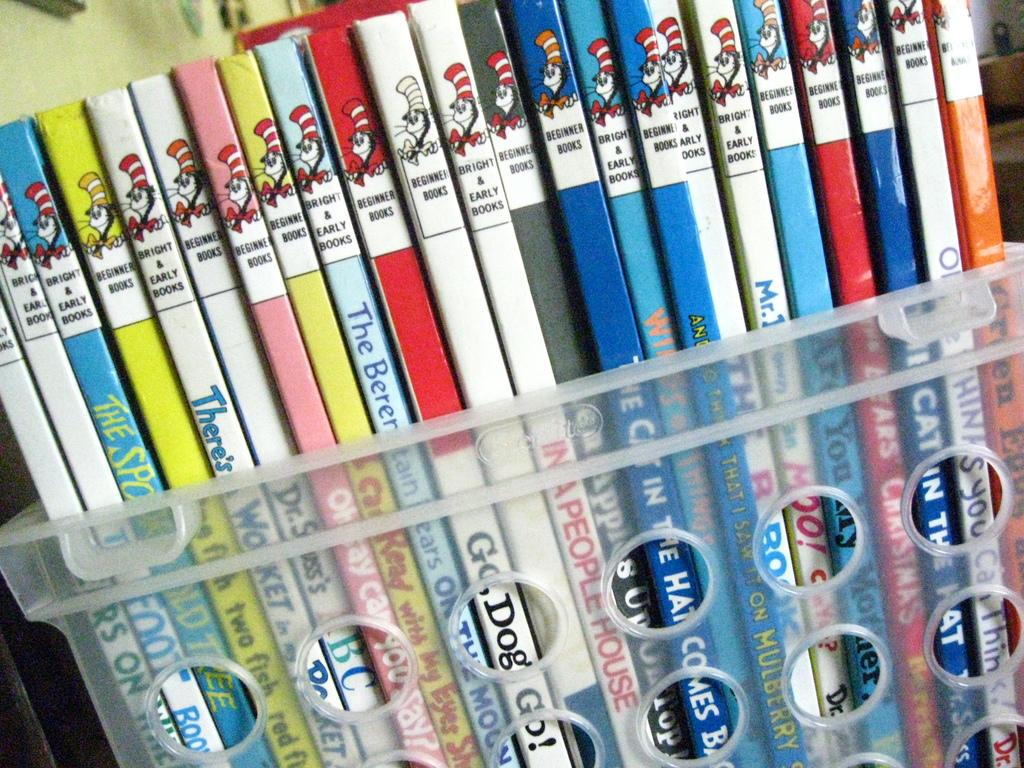What objects can be seen in the image? There are books in the image. How are the books being stored or organized? The books are in a plastic container. What crime is being committed in the image? There is no crime being committed in the image; it only shows books in a plastic container. How does the water drain from the container in the image? There is no water or drain present in the image; it only shows books in a plastic container. 